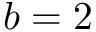Convert formula to latex. <formula><loc_0><loc_0><loc_500><loc_500>b = 2</formula> 